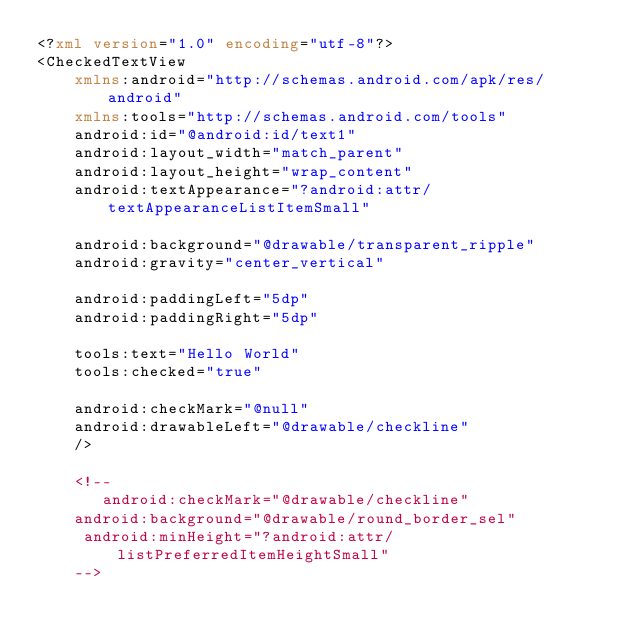<code> <loc_0><loc_0><loc_500><loc_500><_XML_><?xml version="1.0" encoding="utf-8"?>
<CheckedTextView
    xmlns:android="http://schemas.android.com/apk/res/android"
    xmlns:tools="http://schemas.android.com/tools"
    android:id="@android:id/text1"
    android:layout_width="match_parent"
    android:layout_height="wrap_content"
    android:textAppearance="?android:attr/textAppearanceListItemSmall"

    android:background="@drawable/transparent_ripple"
    android:gravity="center_vertical"

    android:paddingLeft="5dp"
    android:paddingRight="5dp"

    tools:text="Hello World"
    tools:checked="true"

    android:checkMark="@null"
    android:drawableLeft="@drawable/checkline"
    />

    <!--
       android:checkMark="@drawable/checkline"
    android:background="@drawable/round_border_sel"
     android:minHeight="?android:attr/listPreferredItemHeightSmall"
    --></code> 